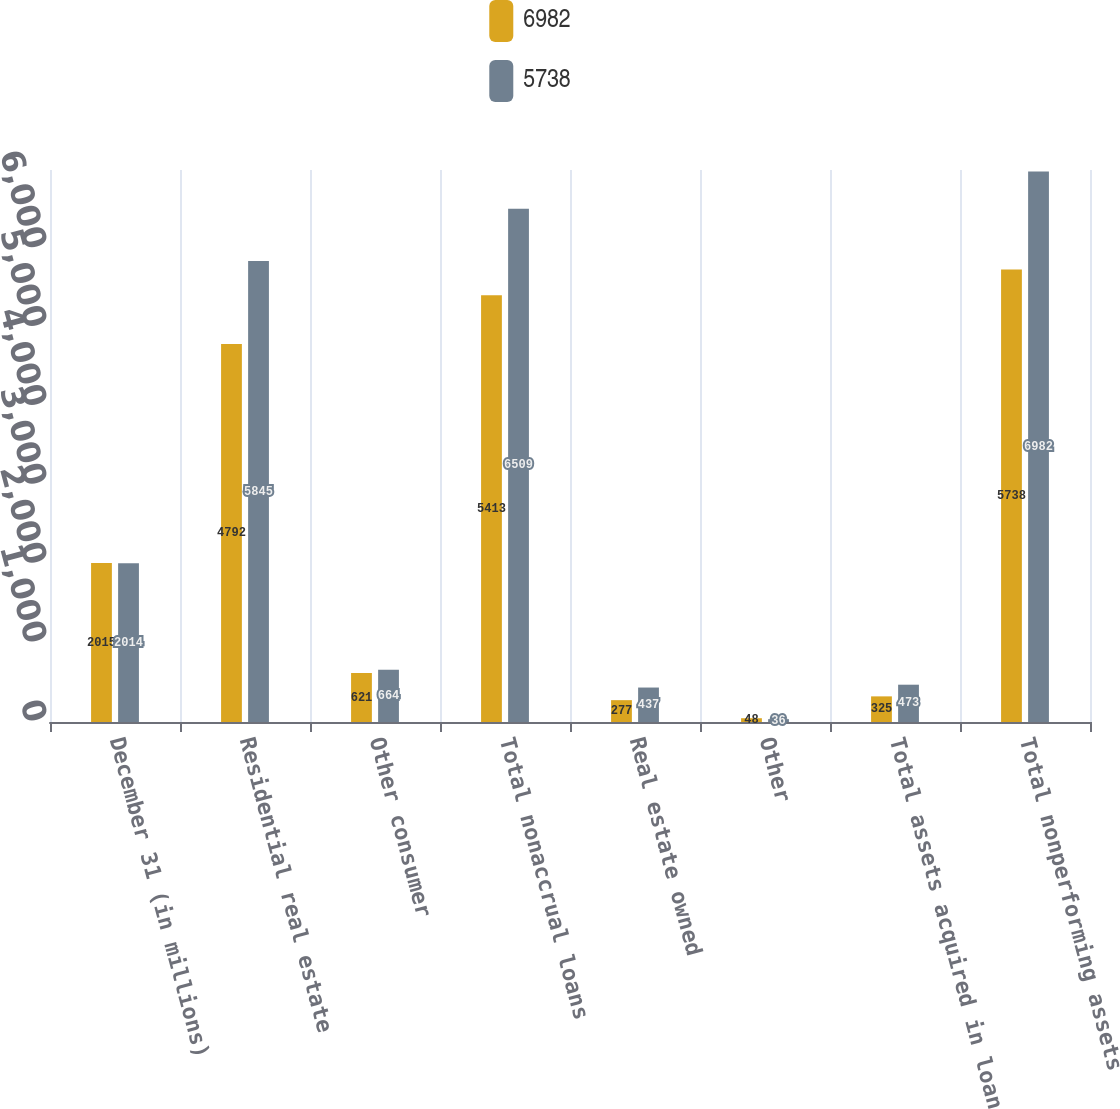<chart> <loc_0><loc_0><loc_500><loc_500><stacked_bar_chart><ecel><fcel>December 31 (in millions)<fcel>Residential real estate<fcel>Other consumer<fcel>Total nonaccrual loans<fcel>Real estate owned<fcel>Other<fcel>Total assets acquired in loan<fcel>Total nonperforming assets<nl><fcel>6982<fcel>2015<fcel>4792<fcel>621<fcel>5413<fcel>277<fcel>48<fcel>325<fcel>5738<nl><fcel>5738<fcel>2014<fcel>5845<fcel>664<fcel>6509<fcel>437<fcel>36<fcel>473<fcel>6982<nl></chart> 